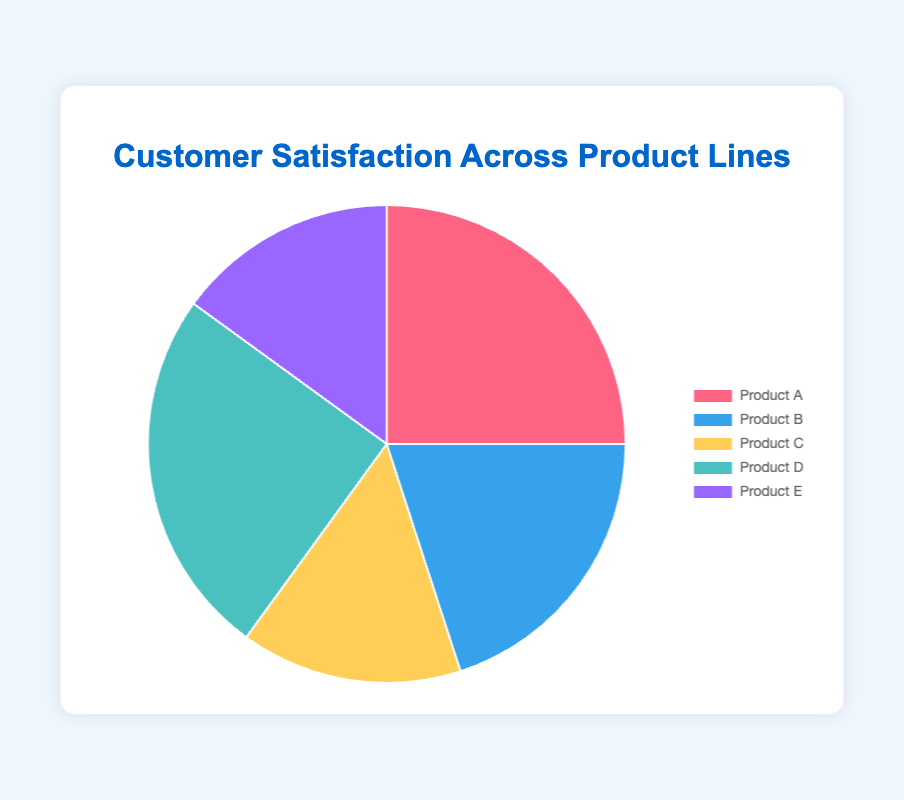Which product has the highest customer satisfaction percentage? From the pie chart, we can see that Product A and Product D both have the highest customer satisfaction percentages, each occupying an equal large segment of the pie chart.
Answer: Product A and Product D Which product has the lowest customer satisfaction percentage? By observing the pie chart, we can see that Product C and Product E have the smallest segments, indicating the lowest customer satisfaction percentages.
Answer: Product C and Product E How does the customer satisfaction percentage of Product B compare with that of Product A? By comparing the sizes of the segments, we see that Product B occupies a smaller portion of the pie chart than Product A, implying that Product B has a lower satisfaction percentage than Product A.
Answer: Product A is higher What is the combined satisfaction percentage for Product C and Product E? From the pie chart, we see that both Product C and Product E have satisfaction percentages of 15%. Summing these values gives us 15% + 15% = 30%.
Answer: 30% What is the difference in satisfaction percentage between Product A and Product B? From the chart, the satisfaction percentages are 25% for Product A and 20% for Product B. Subtracting these values, we get 25% - 20% = 5%.
Answer: 5% What is the average satisfaction percentage across all five products? Adding the satisfaction percentages for all products: 25% (A) + 20% (B) + 15% (C) + 25% (D) + 15% (E) gives 100%. Dividing by 5 (number of products) gives 100% / 5 = 20%.
Answer: 20% If you were to sum the satisfaction percentages of the two most satisfying products, what value would you get? The two most satisfying products are Product A and Product D, each at 25%. Summing these values, we get 25% + 25% = 50%.
Answer: 50% Which product's satisfaction percentage can be represented by the light blue color? Looking at the chart, we can see that the light blue color corresponds to Product E, which has a satisfaction percentage segment colored in light blue.
Answer: Product E What is the satisfaction difference between the product with the highest satisfaction and the product with the lowest satisfaction? The highest satisfaction percentages are 25% (Products A and D). The lowest satisfaction percentages are 15% (Products C and E). The difference is 25% - 15% = 10%.
Answer: 10% 